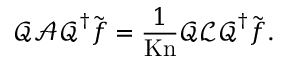Convert formula to latex. <formula><loc_0><loc_0><loc_500><loc_500>\mathcal { Q } \mathcal { A } \mathcal { Q } ^ { \dagger } \tilde { f } = \frac { 1 } { K n } \mathcal { Q } \mathcal { L } \mathcal { Q } ^ { \dagger } \tilde { f } .</formula> 